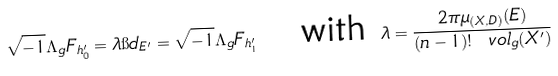Convert formula to latex. <formula><loc_0><loc_0><loc_500><loc_500>\sqrt { - 1 } \Lambda _ { g } F _ { h _ { 0 } ^ { \prime } } = \lambda \i d _ { E ^ { \prime } } = \sqrt { - 1 } \Lambda _ { g } F _ { h _ { 1 } ^ { \prime } } \quad \text {with } \lambda = \frac { 2 \pi \mu _ { ( X , D ) } ( E ) } { ( n - 1 ) ! \ v o l _ { g } ( X ^ { \prime } ) }</formula> 